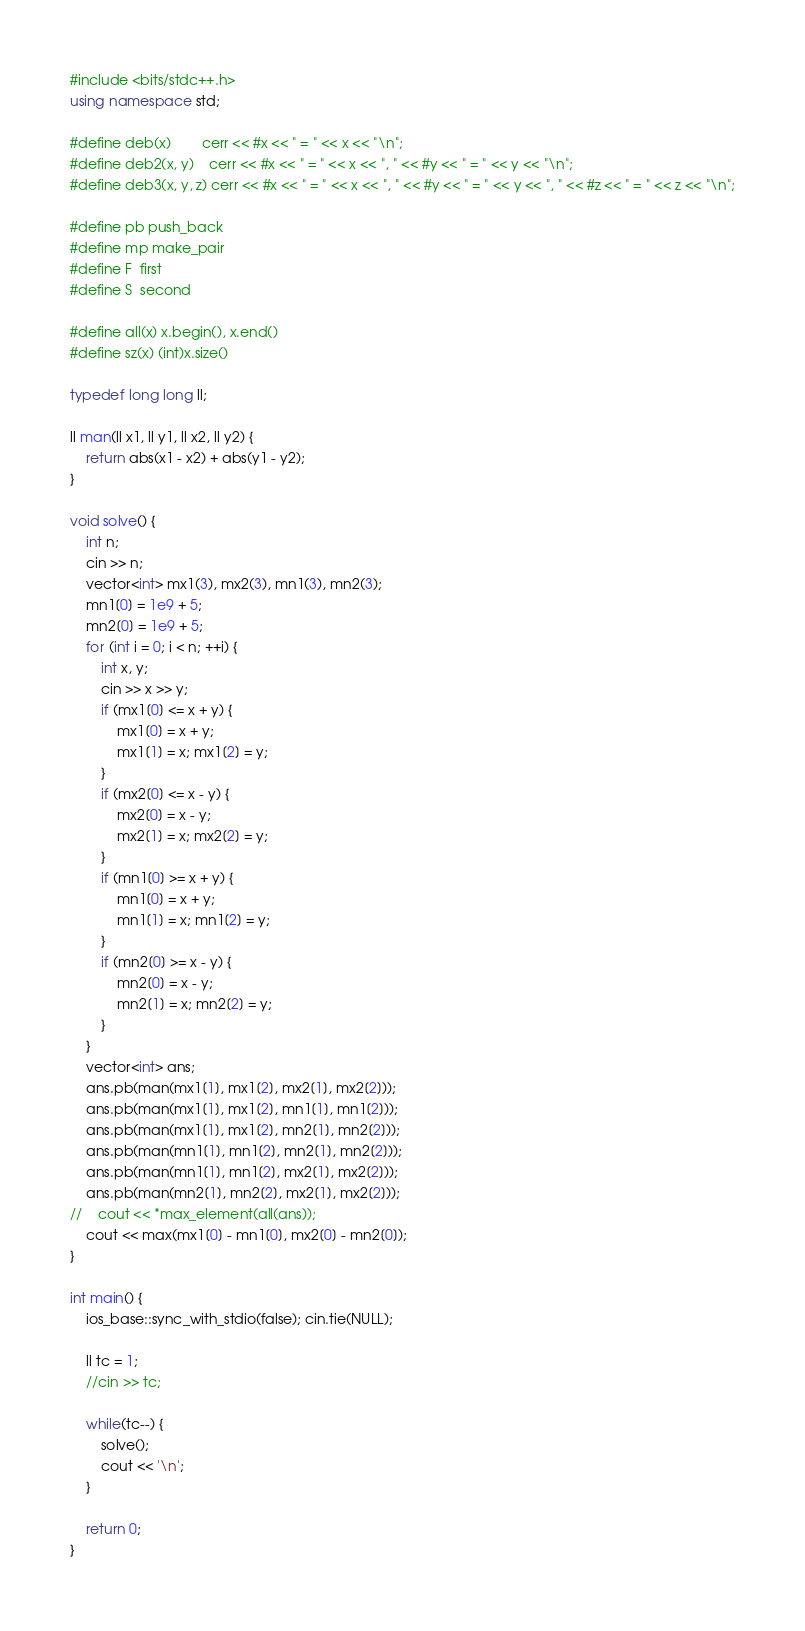Convert code to text. <code><loc_0><loc_0><loc_500><loc_500><_C++_>#include <bits/stdc++.h>
using namespace std;

#define deb(x)        cerr << #x << " = " << x << "\n";
#define deb2(x, y)    cerr << #x << " = " << x << ", " << #y << " = " << y << "\n";
#define deb3(x, y, z) cerr << #x << " = " << x << ", " << #y << " = " << y << ", " << #z << " = " << z << "\n";

#define pb push_back
#define mp make_pair
#define F  first
#define S  second

#define all(x) x.begin(), x.end()
#define sz(x) (int)x.size()

typedef long long ll;  

ll man(ll x1, ll y1, ll x2, ll y2) {
    return abs(x1 - x2) + abs(y1 - y2);
}

void solve() {
    int n;
    cin >> n;
    vector<int> mx1(3), mx2(3), mn1(3), mn2(3);
    mn1[0] = 1e9 + 5;
    mn2[0] = 1e9 + 5;
    for (int i = 0; i < n; ++i) {
        int x, y;
        cin >> x >> y;
        if (mx1[0] <= x + y) {
            mx1[0] = x + y;
            mx1[1] = x; mx1[2] = y;
        }
        if (mx2[0] <= x - y) {
            mx2[0] = x - y;
            mx2[1] = x; mx2[2] = y;
        }
        if (mn1[0] >= x + y) {
            mn1[0] = x + y;
            mn1[1] = x; mn1[2] = y;
        }
        if (mn2[0] >= x - y) {
            mn2[0] = x - y;
            mn2[1] = x; mn2[2] = y;
        }
    }
    vector<int> ans;
    ans.pb(man(mx1[1], mx1[2], mx2[1], mx2[2]));
    ans.pb(man(mx1[1], mx1[2], mn1[1], mn1[2]));
    ans.pb(man(mx1[1], mx1[2], mn2[1], mn2[2]));
    ans.pb(man(mn1[1], mn1[2], mn2[1], mn2[2]));
    ans.pb(man(mn1[1], mn1[2], mx2[1], mx2[2]));
    ans.pb(man(mn2[1], mn2[2], mx2[1], mx2[2]));
//    cout << *max_element(all(ans));
    cout << max(mx1[0] - mn1[0], mx2[0] - mn2[0]);
}

int main() {
    ios_base::sync_with_stdio(false); cin.tie(NULL);

    ll tc = 1;
    //cin >> tc;

    while(tc--) {
        solve();
        cout << '\n';
    }

    return 0;
}

</code> 